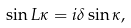Convert formula to latex. <formula><loc_0><loc_0><loc_500><loc_500>\sin L \kappa = i \delta \sin \kappa ,</formula> 